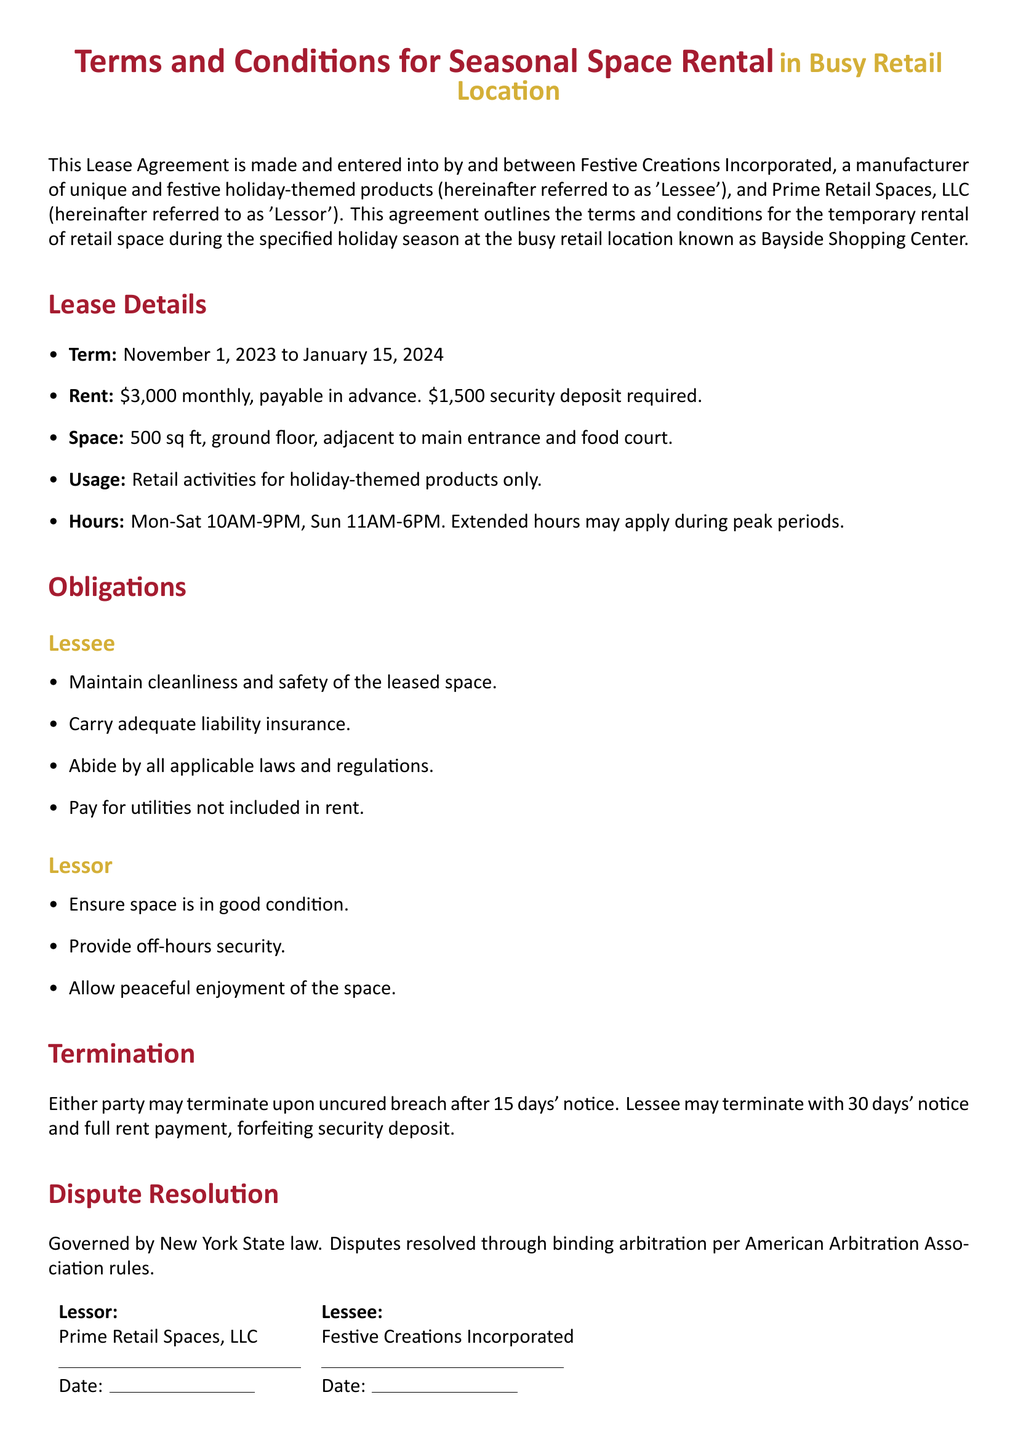What is the lease term? The lease term is specified in the document, running from November 1, 2023 to January 15, 2024.
Answer: November 1, 2023 to January 15, 2024 What is the monthly rent? The document states that the monthly rent is $3,000, which must be paid in advance.
Answer: $3,000 How much is the security deposit? The lease agreement specifies a security deposit of $1,500 that is required.
Answer: $1,500 What type of products can be sold? The document specifies that the leased space is for retail activities for holiday-themed products only.
Answer: Holiday-themed products What hours is the retail space open? The hours of operation are detailed in the lease, which states Mon-Sat 10AM-9PM and Sun 11AM-6PM.
Answer: Mon-Sat 10AM-9PM, Sun 11AM-6PM Who is responsible for maintaining cleanliness? According to the obligations section for the Lessee, they are required to maintain cleanliness and safety of the leased space.
Answer: Lessee What is the method for resolving disputes? The lease outlines that disputes will be resolved through binding arbitration per American Arbitration Association rules.
Answer: Binding arbitration What happens if a party breaches the agreement? The document states that either party may terminate upon uncured breach after 15 days' notice.
Answer: 15 days' notice What will happen to the security deposit upon termination? The agreement specifies that the Lessee, upon termination, will forfeit the security deposit if they terminate with 30 days' notice.
Answer: Forfeit What laws govern the lease agreement? The document mentions that the lease agreement is governed by New York State law.
Answer: New York State law 